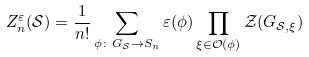Convert formula to latex. <formula><loc_0><loc_0><loc_500><loc_500>Z _ { n } ^ { \varepsilon } ( \mathcal { S } ) = \frac { 1 } { n ! } \sum _ { \phi \colon G _ { \mathcal { S } } \rightarrow S _ { n } } \varepsilon ( \phi ) \prod _ { \xi \in \mathcal { O } ( \phi ) } \mathcal { Z } ( G _ { \mathcal { S } , \xi } )</formula> 